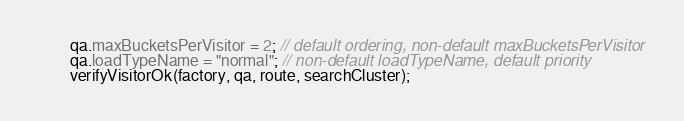<code> <loc_0><loc_0><loc_500><loc_500><_Java_>        qa.maxBucketsPerVisitor = 2; // default ordering, non-default maxBucketsPerVisitor
        qa.loadTypeName = "normal"; // non-default loadTypeName, default priority
        verifyVisitorOk(factory, qa, route, searchCluster);
</code> 